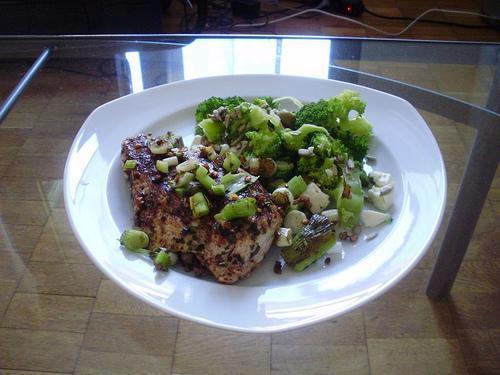How many broccolis are visible?
Give a very brief answer. 3. 